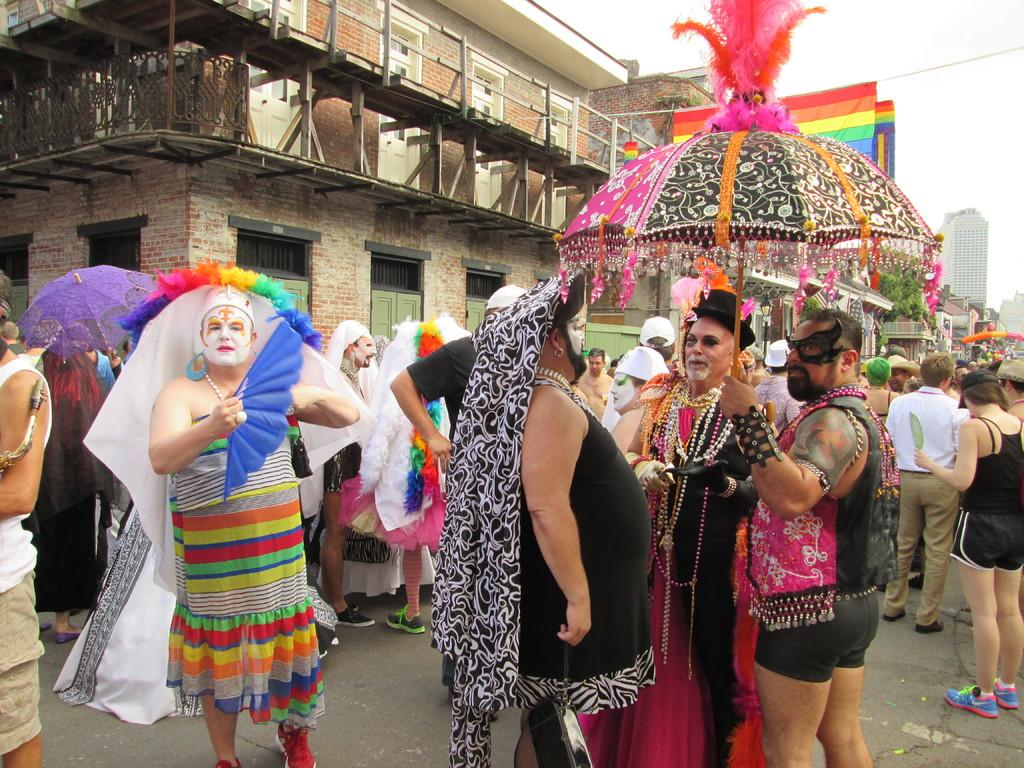What is the main subject of the image? The main subject of the image is a crowd of people. What are the people in the crowd holding? The people in the crowd are holding umbrellas. What can be seen in the background of the image? There are buildings in the background of the image. What number is written as a caption on the image? There is no number written as a caption on the image. What type of destruction can be seen happening to the buildings in the image? There is no destruction visible in the image; the buildings appear intact. 